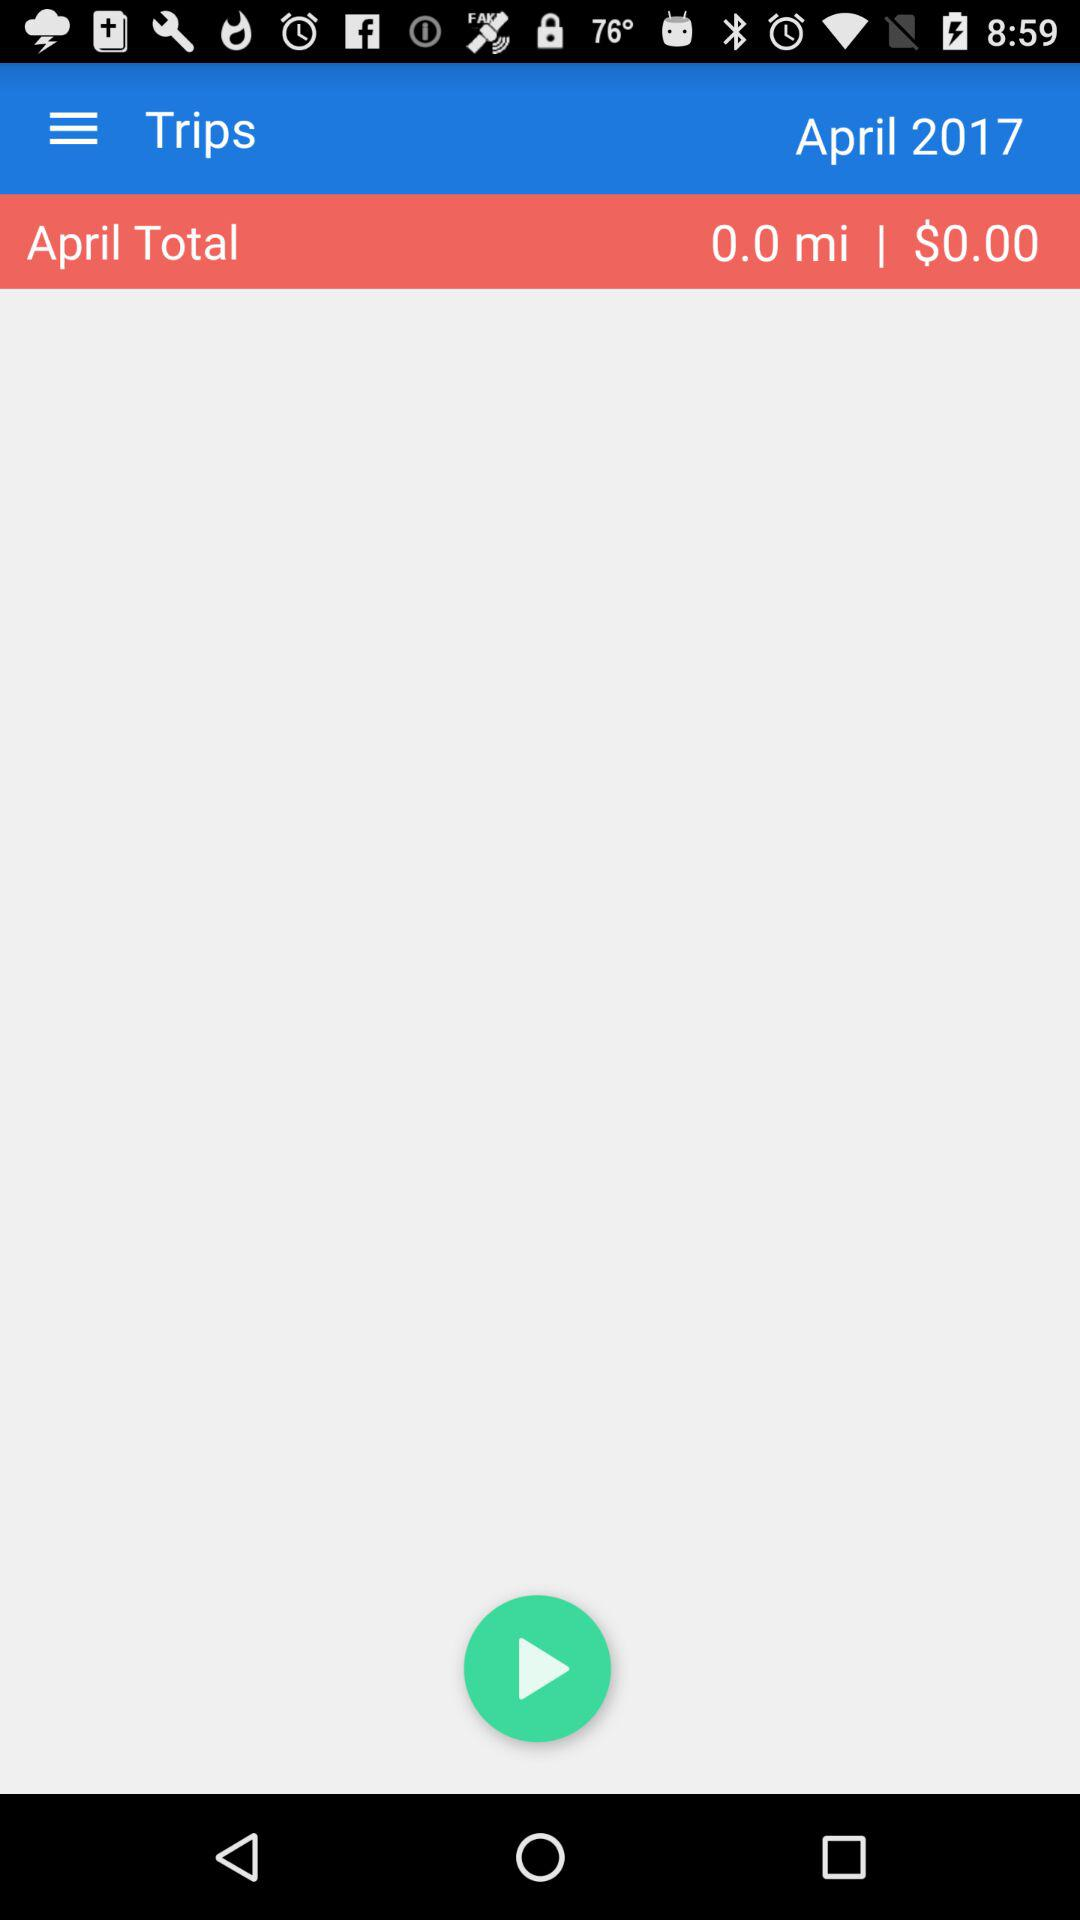How much money was spent in April?
Answer the question using a single word or phrase. $0.00 